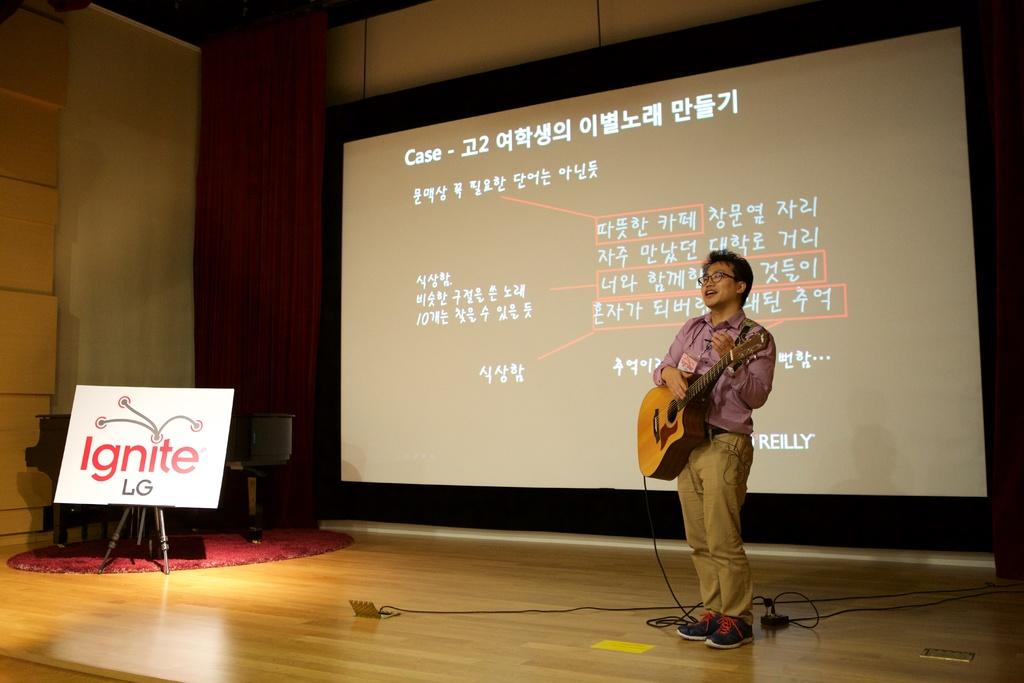Who is the person in the image? There is a man in the image. What is the man holding in the image? The man is holding a guitar. What is the man doing with the guitar? The man is playing the guitar. What can be seen in the background of the image? There is a board and a projector screen in the background of the image. What type of yoke is the man wearing in the image? There is no yoke present in the image; the man is holding and playing a guitar. 